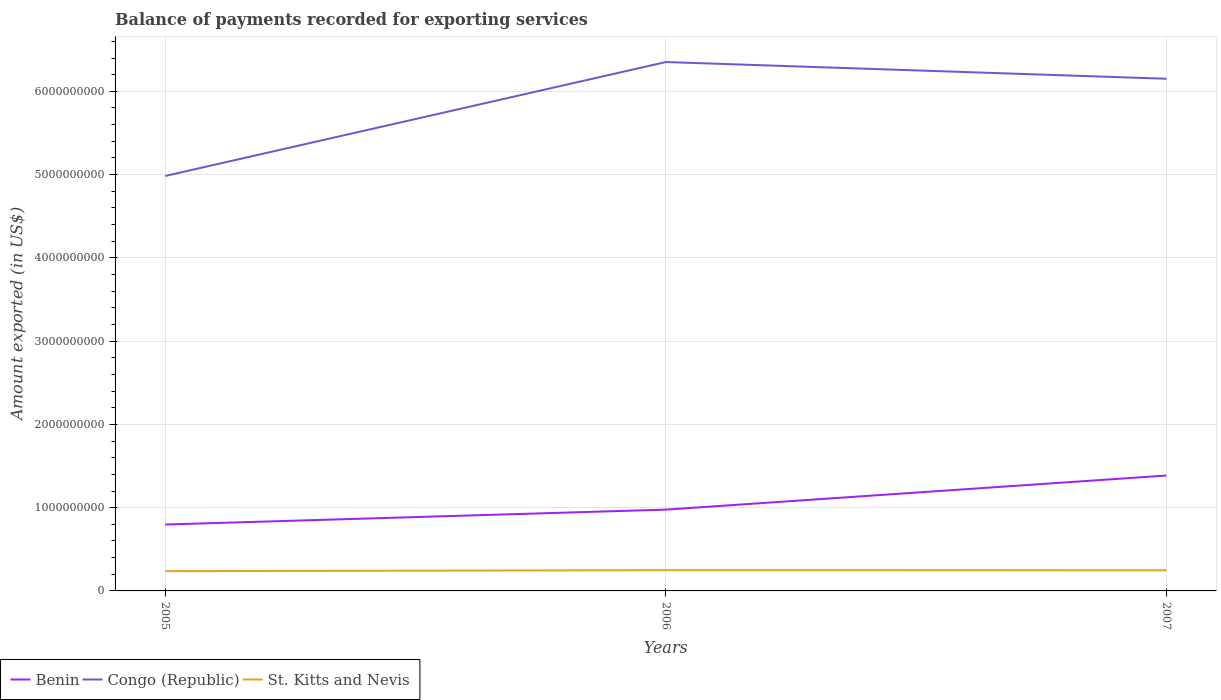How many different coloured lines are there?
Your answer should be very brief. 3. Across all years, what is the maximum amount exported in Congo (Republic)?
Provide a succinct answer. 4.98e+09. What is the total amount exported in Benin in the graph?
Ensure brevity in your answer.  -4.10e+08. What is the difference between the highest and the second highest amount exported in St. Kitts and Nevis?
Give a very brief answer. 1.17e+07. What is the difference between two consecutive major ticks on the Y-axis?
Offer a terse response. 1.00e+09. Does the graph contain any zero values?
Provide a short and direct response. No. Does the graph contain grids?
Ensure brevity in your answer.  Yes. Where does the legend appear in the graph?
Make the answer very short. Bottom left. How many legend labels are there?
Ensure brevity in your answer.  3. What is the title of the graph?
Keep it short and to the point. Balance of payments recorded for exporting services. Does "Tanzania" appear as one of the legend labels in the graph?
Ensure brevity in your answer.  No. What is the label or title of the X-axis?
Keep it short and to the point. Years. What is the label or title of the Y-axis?
Give a very brief answer. Amount exported (in US$). What is the Amount exported (in US$) of Benin in 2005?
Ensure brevity in your answer.  7.97e+08. What is the Amount exported (in US$) of Congo (Republic) in 2005?
Your answer should be very brief. 4.98e+09. What is the Amount exported (in US$) in St. Kitts and Nevis in 2005?
Your answer should be compact. 2.37e+08. What is the Amount exported (in US$) in Benin in 2006?
Your response must be concise. 9.76e+08. What is the Amount exported (in US$) of Congo (Republic) in 2006?
Keep it short and to the point. 6.35e+09. What is the Amount exported (in US$) in St. Kitts and Nevis in 2006?
Offer a terse response. 2.49e+08. What is the Amount exported (in US$) of Benin in 2007?
Keep it short and to the point. 1.39e+09. What is the Amount exported (in US$) of Congo (Republic) in 2007?
Your answer should be compact. 6.15e+09. What is the Amount exported (in US$) of St. Kitts and Nevis in 2007?
Offer a very short reply. 2.48e+08. Across all years, what is the maximum Amount exported (in US$) of Benin?
Your response must be concise. 1.39e+09. Across all years, what is the maximum Amount exported (in US$) in Congo (Republic)?
Make the answer very short. 6.35e+09. Across all years, what is the maximum Amount exported (in US$) of St. Kitts and Nevis?
Offer a very short reply. 2.49e+08. Across all years, what is the minimum Amount exported (in US$) of Benin?
Your answer should be compact. 7.97e+08. Across all years, what is the minimum Amount exported (in US$) of Congo (Republic)?
Offer a terse response. 4.98e+09. Across all years, what is the minimum Amount exported (in US$) of St. Kitts and Nevis?
Give a very brief answer. 2.37e+08. What is the total Amount exported (in US$) in Benin in the graph?
Provide a short and direct response. 3.16e+09. What is the total Amount exported (in US$) in Congo (Republic) in the graph?
Your answer should be compact. 1.75e+1. What is the total Amount exported (in US$) in St. Kitts and Nevis in the graph?
Provide a short and direct response. 7.34e+08. What is the difference between the Amount exported (in US$) of Benin in 2005 and that in 2006?
Your answer should be compact. -1.79e+08. What is the difference between the Amount exported (in US$) in Congo (Republic) in 2005 and that in 2006?
Provide a short and direct response. -1.37e+09. What is the difference between the Amount exported (in US$) of St. Kitts and Nevis in 2005 and that in 2006?
Ensure brevity in your answer.  -1.17e+07. What is the difference between the Amount exported (in US$) of Benin in 2005 and that in 2007?
Give a very brief answer. -5.89e+08. What is the difference between the Amount exported (in US$) in Congo (Republic) in 2005 and that in 2007?
Offer a very short reply. -1.17e+09. What is the difference between the Amount exported (in US$) in St. Kitts and Nevis in 2005 and that in 2007?
Give a very brief answer. -1.04e+07. What is the difference between the Amount exported (in US$) in Benin in 2006 and that in 2007?
Keep it short and to the point. -4.10e+08. What is the difference between the Amount exported (in US$) of Congo (Republic) in 2006 and that in 2007?
Ensure brevity in your answer.  2.01e+08. What is the difference between the Amount exported (in US$) of St. Kitts and Nevis in 2006 and that in 2007?
Ensure brevity in your answer.  1.23e+06. What is the difference between the Amount exported (in US$) in Benin in 2005 and the Amount exported (in US$) in Congo (Republic) in 2006?
Your response must be concise. -5.55e+09. What is the difference between the Amount exported (in US$) of Benin in 2005 and the Amount exported (in US$) of St. Kitts and Nevis in 2006?
Keep it short and to the point. 5.48e+08. What is the difference between the Amount exported (in US$) of Congo (Republic) in 2005 and the Amount exported (in US$) of St. Kitts and Nevis in 2006?
Provide a short and direct response. 4.73e+09. What is the difference between the Amount exported (in US$) in Benin in 2005 and the Amount exported (in US$) in Congo (Republic) in 2007?
Keep it short and to the point. -5.35e+09. What is the difference between the Amount exported (in US$) of Benin in 2005 and the Amount exported (in US$) of St. Kitts and Nevis in 2007?
Ensure brevity in your answer.  5.50e+08. What is the difference between the Amount exported (in US$) in Congo (Republic) in 2005 and the Amount exported (in US$) in St. Kitts and Nevis in 2007?
Ensure brevity in your answer.  4.74e+09. What is the difference between the Amount exported (in US$) of Benin in 2006 and the Amount exported (in US$) of Congo (Republic) in 2007?
Provide a short and direct response. -5.17e+09. What is the difference between the Amount exported (in US$) in Benin in 2006 and the Amount exported (in US$) in St. Kitts and Nevis in 2007?
Your answer should be very brief. 7.29e+08. What is the difference between the Amount exported (in US$) in Congo (Republic) in 2006 and the Amount exported (in US$) in St. Kitts and Nevis in 2007?
Your response must be concise. 6.10e+09. What is the average Amount exported (in US$) of Benin per year?
Ensure brevity in your answer.  1.05e+09. What is the average Amount exported (in US$) of Congo (Republic) per year?
Your response must be concise. 5.83e+09. What is the average Amount exported (in US$) in St. Kitts and Nevis per year?
Give a very brief answer. 2.45e+08. In the year 2005, what is the difference between the Amount exported (in US$) of Benin and Amount exported (in US$) of Congo (Republic)?
Give a very brief answer. -4.19e+09. In the year 2005, what is the difference between the Amount exported (in US$) of Benin and Amount exported (in US$) of St. Kitts and Nevis?
Make the answer very short. 5.60e+08. In the year 2005, what is the difference between the Amount exported (in US$) in Congo (Republic) and Amount exported (in US$) in St. Kitts and Nevis?
Provide a succinct answer. 4.75e+09. In the year 2006, what is the difference between the Amount exported (in US$) in Benin and Amount exported (in US$) in Congo (Republic)?
Your answer should be compact. -5.38e+09. In the year 2006, what is the difference between the Amount exported (in US$) of Benin and Amount exported (in US$) of St. Kitts and Nevis?
Keep it short and to the point. 7.27e+08. In the year 2006, what is the difference between the Amount exported (in US$) of Congo (Republic) and Amount exported (in US$) of St. Kitts and Nevis?
Your answer should be compact. 6.10e+09. In the year 2007, what is the difference between the Amount exported (in US$) of Benin and Amount exported (in US$) of Congo (Republic)?
Offer a terse response. -4.76e+09. In the year 2007, what is the difference between the Amount exported (in US$) in Benin and Amount exported (in US$) in St. Kitts and Nevis?
Give a very brief answer. 1.14e+09. In the year 2007, what is the difference between the Amount exported (in US$) in Congo (Republic) and Amount exported (in US$) in St. Kitts and Nevis?
Ensure brevity in your answer.  5.90e+09. What is the ratio of the Amount exported (in US$) in Benin in 2005 to that in 2006?
Give a very brief answer. 0.82. What is the ratio of the Amount exported (in US$) in Congo (Republic) in 2005 to that in 2006?
Your answer should be compact. 0.78. What is the ratio of the Amount exported (in US$) in St. Kitts and Nevis in 2005 to that in 2006?
Provide a succinct answer. 0.95. What is the ratio of the Amount exported (in US$) in Benin in 2005 to that in 2007?
Give a very brief answer. 0.58. What is the ratio of the Amount exported (in US$) in Congo (Republic) in 2005 to that in 2007?
Keep it short and to the point. 0.81. What is the ratio of the Amount exported (in US$) in St. Kitts and Nevis in 2005 to that in 2007?
Make the answer very short. 0.96. What is the ratio of the Amount exported (in US$) of Benin in 2006 to that in 2007?
Keep it short and to the point. 0.7. What is the ratio of the Amount exported (in US$) of Congo (Republic) in 2006 to that in 2007?
Keep it short and to the point. 1.03. What is the ratio of the Amount exported (in US$) in St. Kitts and Nevis in 2006 to that in 2007?
Make the answer very short. 1. What is the difference between the highest and the second highest Amount exported (in US$) of Benin?
Provide a short and direct response. 4.10e+08. What is the difference between the highest and the second highest Amount exported (in US$) in Congo (Republic)?
Ensure brevity in your answer.  2.01e+08. What is the difference between the highest and the second highest Amount exported (in US$) in St. Kitts and Nevis?
Provide a succinct answer. 1.23e+06. What is the difference between the highest and the lowest Amount exported (in US$) of Benin?
Your answer should be very brief. 5.89e+08. What is the difference between the highest and the lowest Amount exported (in US$) in Congo (Republic)?
Your answer should be very brief. 1.37e+09. What is the difference between the highest and the lowest Amount exported (in US$) of St. Kitts and Nevis?
Your answer should be compact. 1.17e+07. 